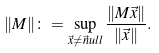<formula> <loc_0><loc_0><loc_500><loc_500>\| M \| \colon = \sup _ { \vec { x } \neq \vec { n } u l l } \frac { \| M \vec { x } \| } { \| \vec { x } \| } .</formula> 